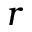<formula> <loc_0><loc_0><loc_500><loc_500>r</formula> 